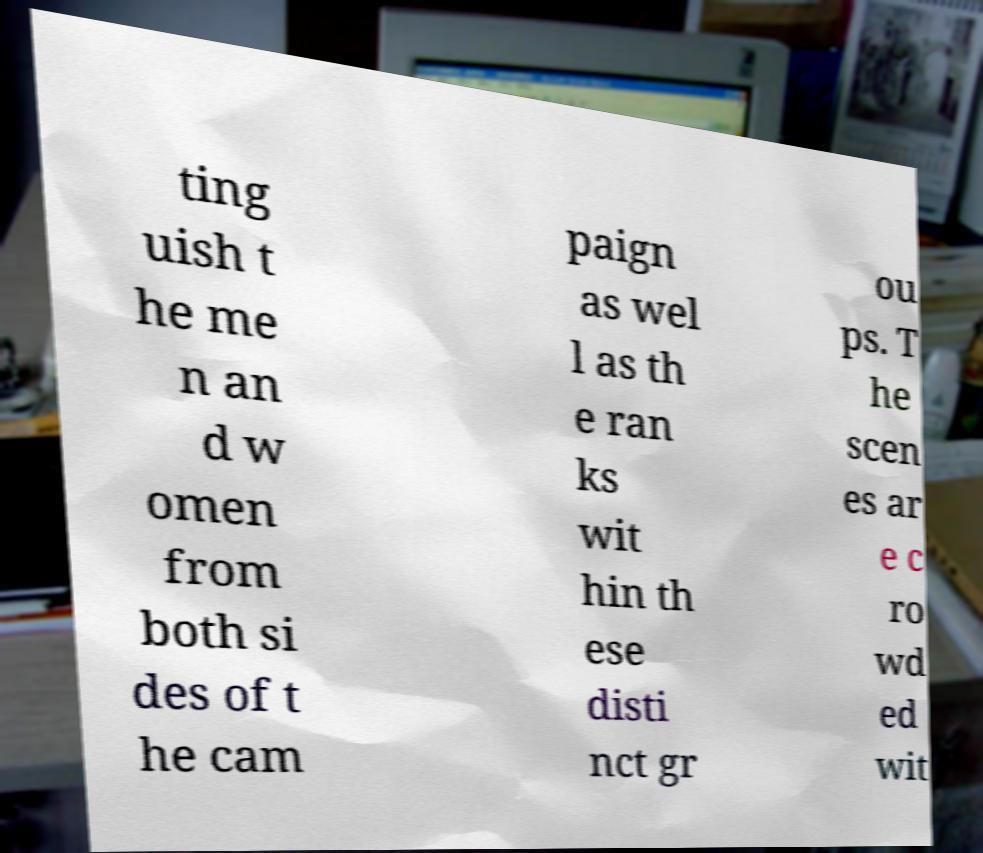Please read and relay the text visible in this image. What does it say? ting uish t he me n an d w omen from both si des of t he cam paign as wel l as th e ran ks wit hin th ese disti nct gr ou ps. T he scen es ar e c ro wd ed wit 